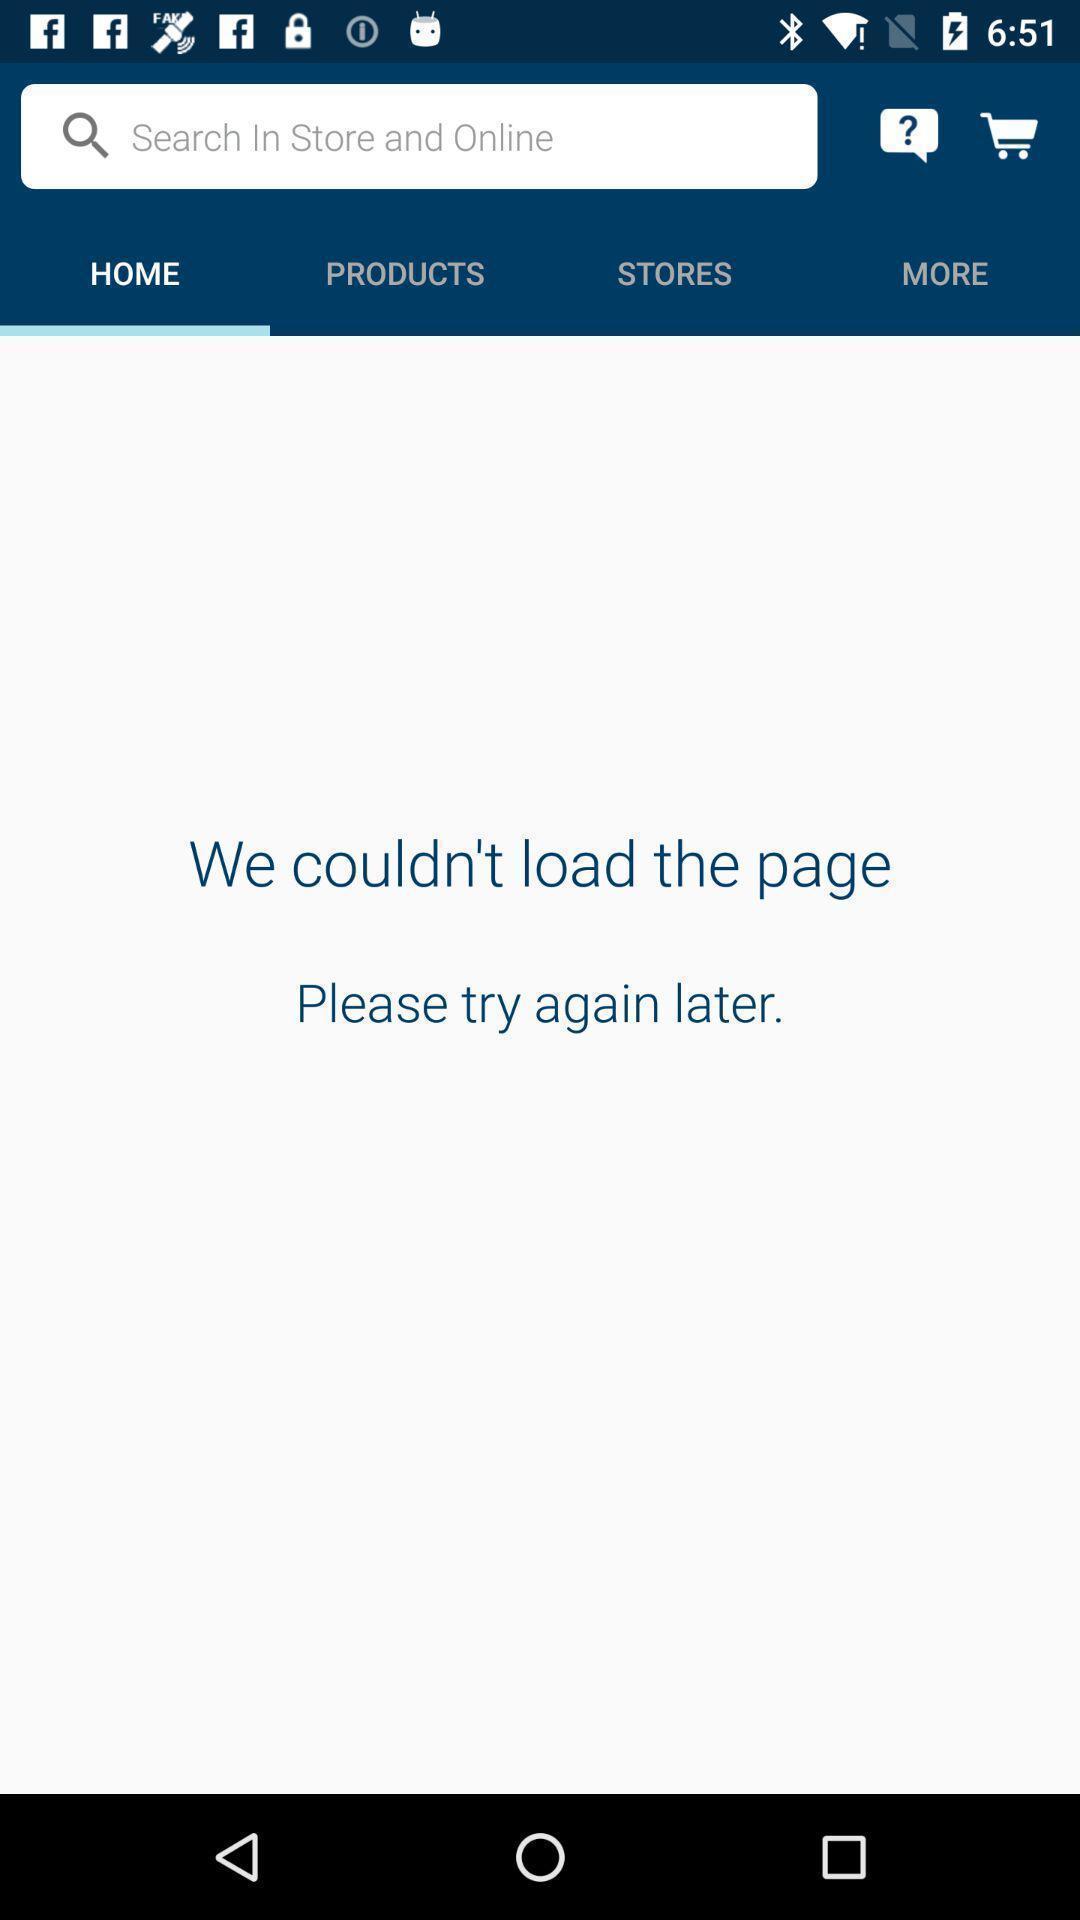Give me a summary of this screen capture. Screen shows an unloaded home page. 